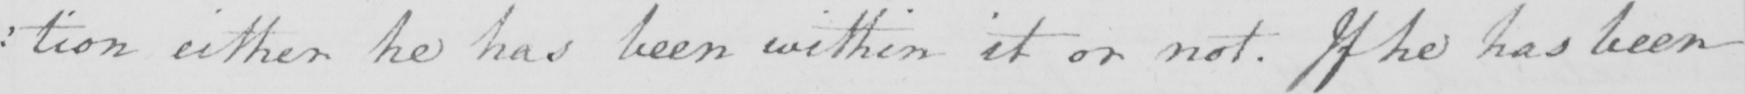Please provide the text content of this handwritten line. : tion either he has been within it or not . If he has been 